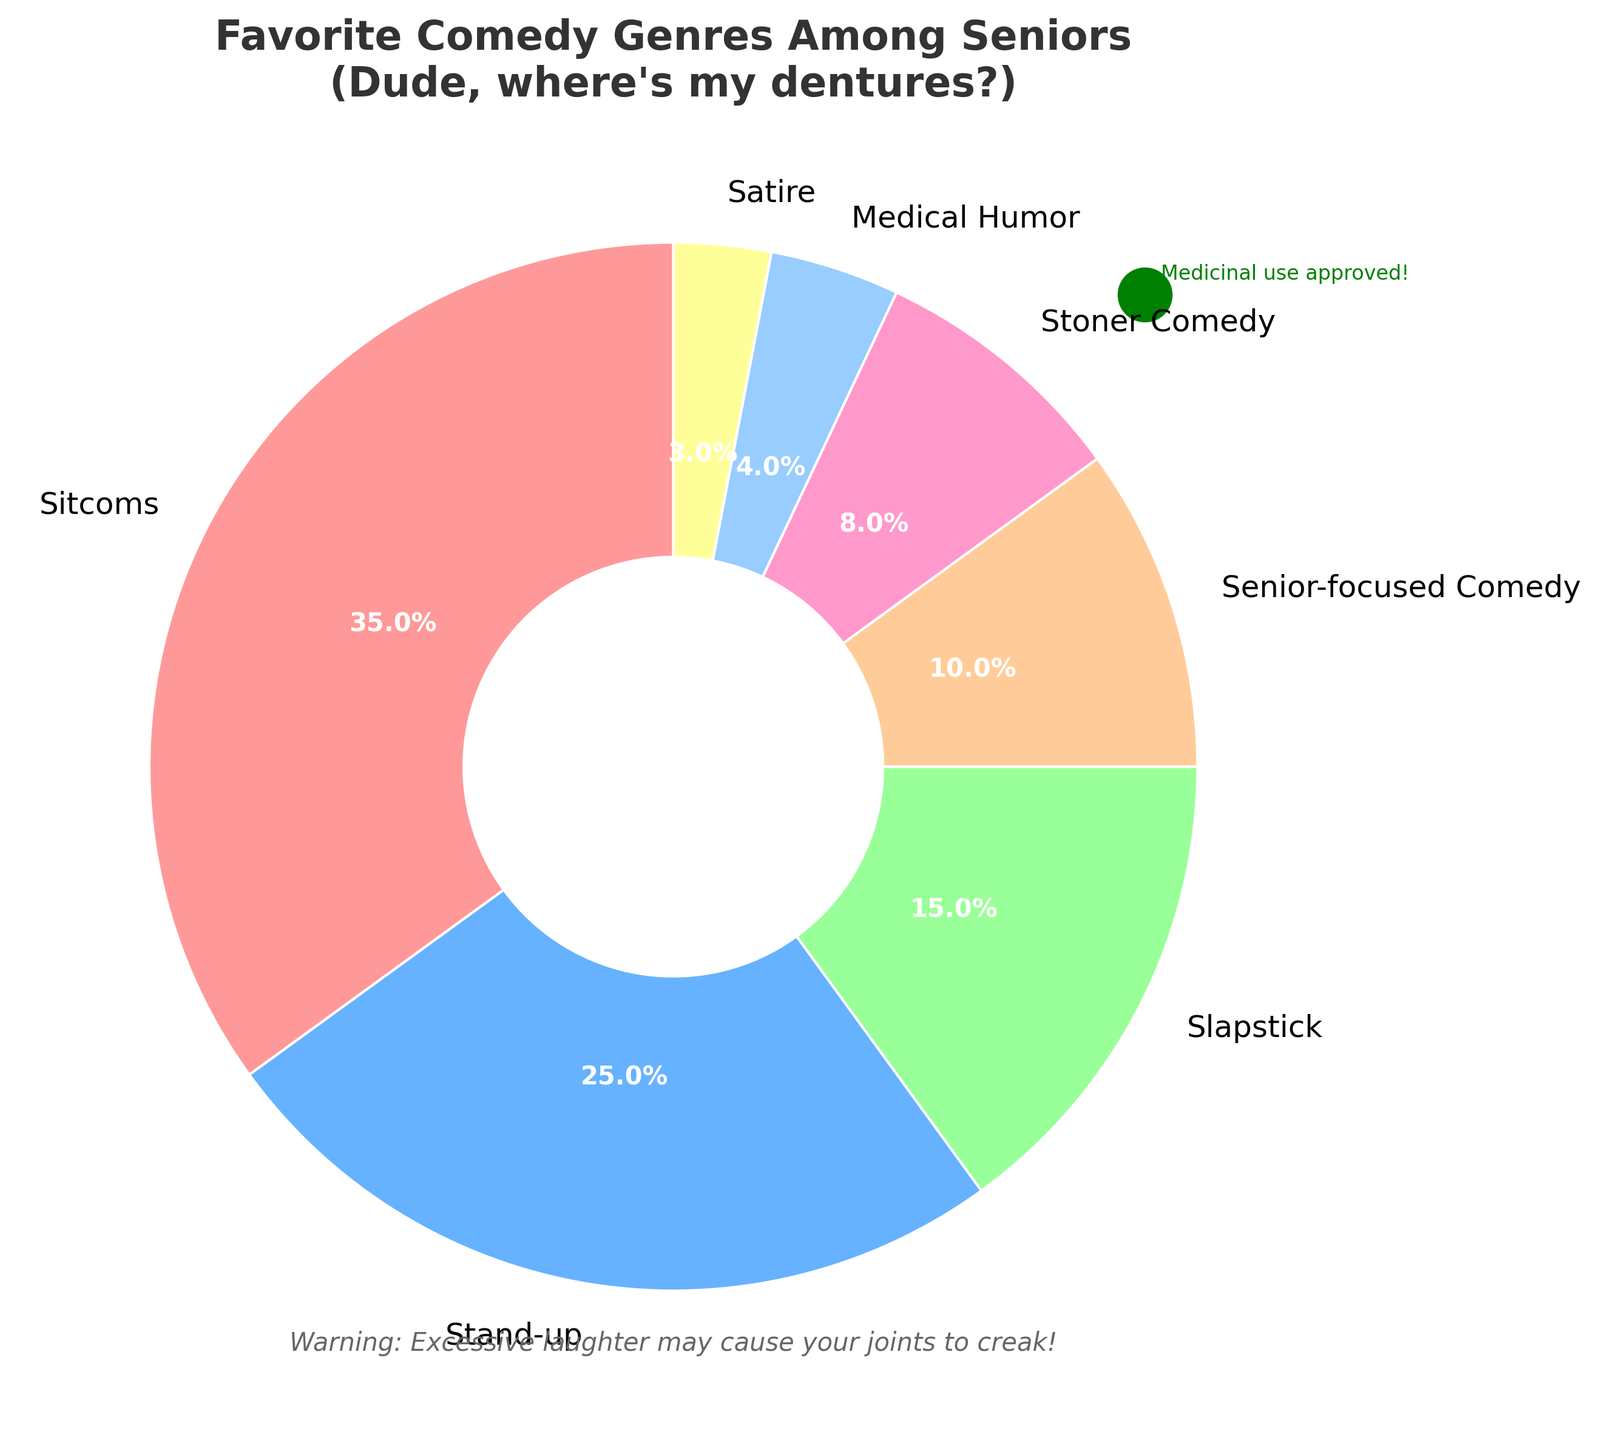What's the most popular comedy genre among seniors? The pie chart shows the largest wedge representing 35% for Sitcoms, which indicates it is the most popular genre.
Answer: Sitcoms Which comedy genre is favored the least by seniors? The smallest wedge in the pie chart represents 3%, which corresponds to Satire, making it the least favored genre.
Answer: Satire How do the percentages of Sitcoms and Stand-up combined compare to 50%? Adding the percentages for Sitcoms and Stand-up gives 35% + 25% = 60%. Since 60% is greater than 50%, the combination surpasses half of the total.
Answer: Greater than 50% Which comedy genres combined make up exactly half of the total percentage? Adding genres Senior-focused Comedy (10%), Stoner Comedy (8%), Medical Humor (4%), and Satire (3%) totals 10% + 8% + 4% + 3% = 25%. However, combining just Sitcoms (35%) and Slapstick (15%) gives 35% + 15% = 50%, which makes up half of the total percentage.
Answer: Sitcoms and Slapstick How many comedy genres are less popular than Slapstick among seniors? From the pie chart, the genres lower in percentage than Slapstick (15%) are Senior-focused Comedy (10%), Stoner Comedy (8%), Medical Humor (4%), and Satire (3%). There are four such genres.
Answer: Four By how much does the percentage of Stand-up exceed that of Stoner Comedy? Stand-up accounts for 25%, and Stoner Comedy for 8%. The difference is 25% - 8% = 17%.
Answer: 17% Are there more seniors who prefer Medical Humor or Stoner Comedy? From the chart, Medical Humor accounts for 4%, while Stoner Comedy is at 8%. Since 8% is greater than 4%, more seniors prefer Stoner Comedy.
Answer: Stoner Comedy What's the percentage difference between the most and least favored comedy genres? The highest percentage is for Sitcoms at 35%, and the lowest is for Satire at 3%. The difference is 35% - 3% = 32%.
Answer: 32% 